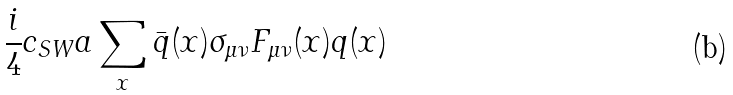Convert formula to latex. <formula><loc_0><loc_0><loc_500><loc_500>\frac { i } { 4 } c _ { S W } a \sum _ { x } \bar { q } ( x ) \sigma _ { \mu \nu } F _ { \mu \nu } ( x ) q ( x ) \,</formula> 